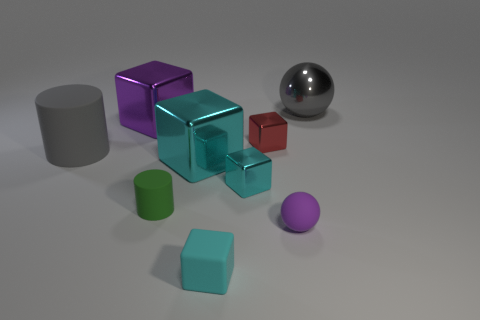Subtract all tiny blocks. How many blocks are left? 2 Subtract all cyan cubes. How many cubes are left? 2 Add 1 green rubber cylinders. How many green rubber cylinders exist? 2 Subtract 1 gray cylinders. How many objects are left? 8 Subtract all balls. How many objects are left? 7 Subtract 1 cylinders. How many cylinders are left? 1 Subtract all yellow balls. Subtract all brown cylinders. How many balls are left? 2 Subtract all green balls. How many cyan cubes are left? 3 Subtract all big gray cylinders. Subtract all large purple shiny objects. How many objects are left? 7 Add 2 small red metallic things. How many small red metallic things are left? 3 